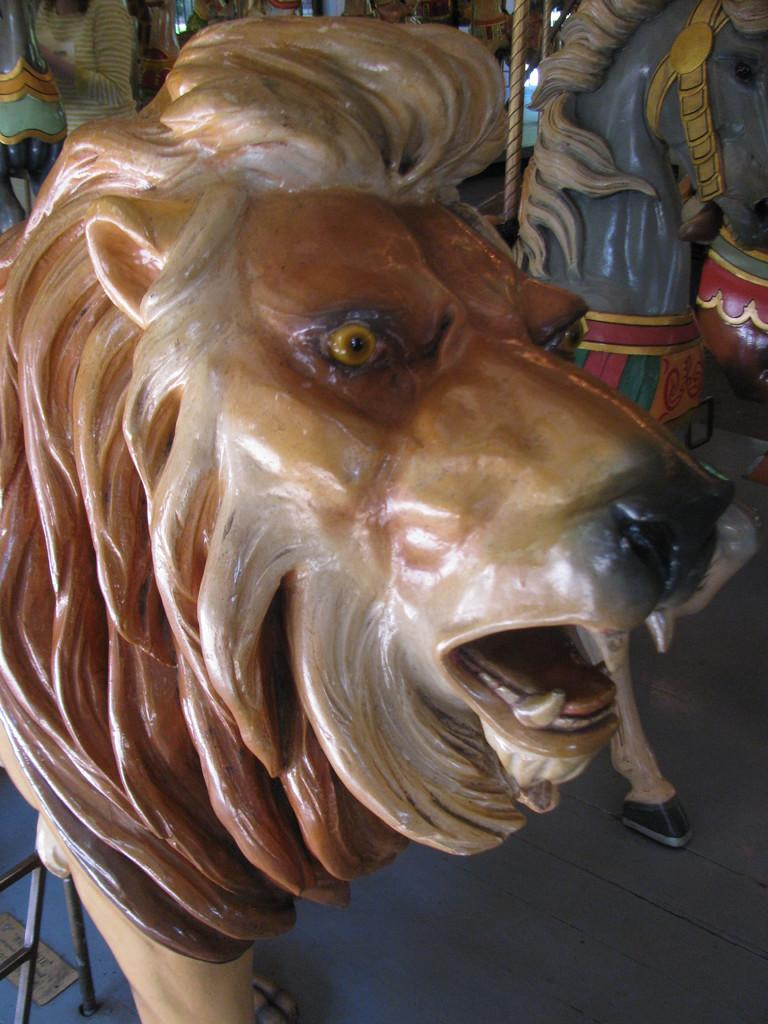What can be seen on the floor in the image? There are statues on the floor in the image. Are there any other subjects or objects in the image besides the statues? Yes, there are people in the image. What type of seed is being planted by the people in the image? There is no seed or planting activity depicted in the image; it only shows statues on the floor and people. What rhythm are the statues dancing to in the image? The statues are not dancing in the image, so there is no rhythm to be considered. 